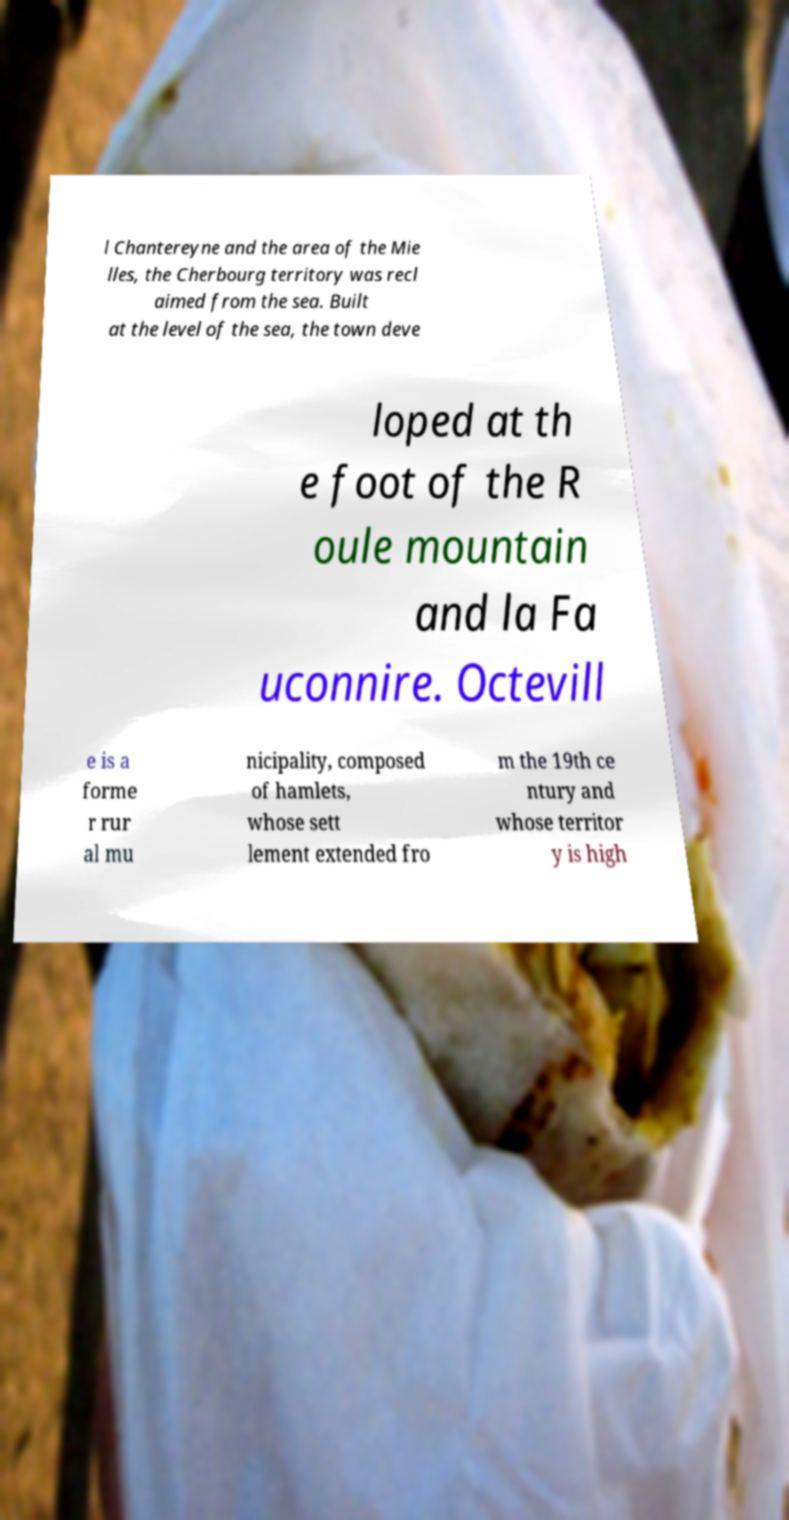I need the written content from this picture converted into text. Can you do that? l Chantereyne and the area of the Mie lles, the Cherbourg territory was recl aimed from the sea. Built at the level of the sea, the town deve loped at th e foot of the R oule mountain and la Fa uconnire. Octevill e is a forme r rur al mu nicipality, composed of hamlets, whose sett lement extended fro m the 19th ce ntury and whose territor y is high 